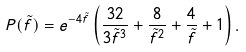Convert formula to latex. <formula><loc_0><loc_0><loc_500><loc_500>P ( \tilde { f } ) = e ^ { - 4 \tilde { f } } \left ( \frac { 3 2 } { 3 \tilde { f } ^ { 3 } } + \frac { 8 } { \tilde { f } ^ { 2 } } + \frac { 4 } { \tilde { f } } + 1 \right ) .</formula> 